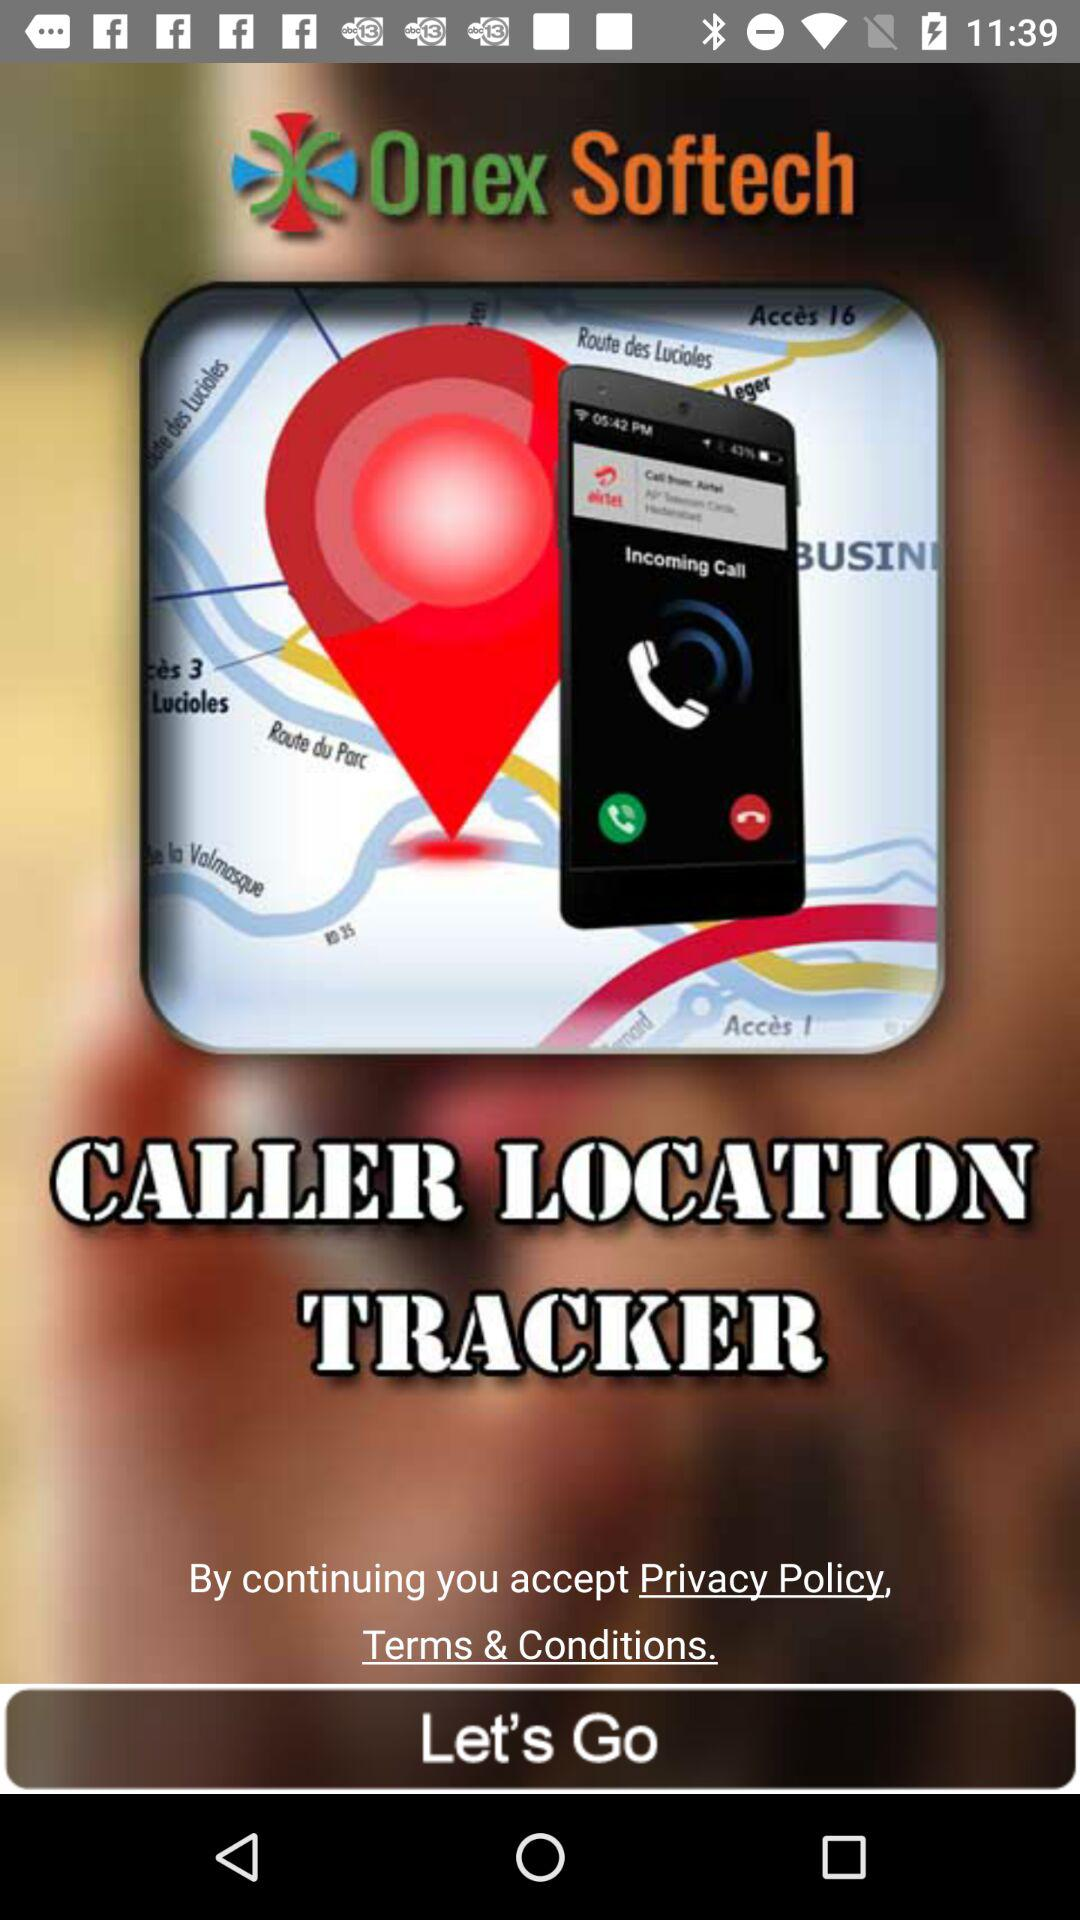What is the name of the application? The name of the application is "CALLER LOCATION TRACKER". 